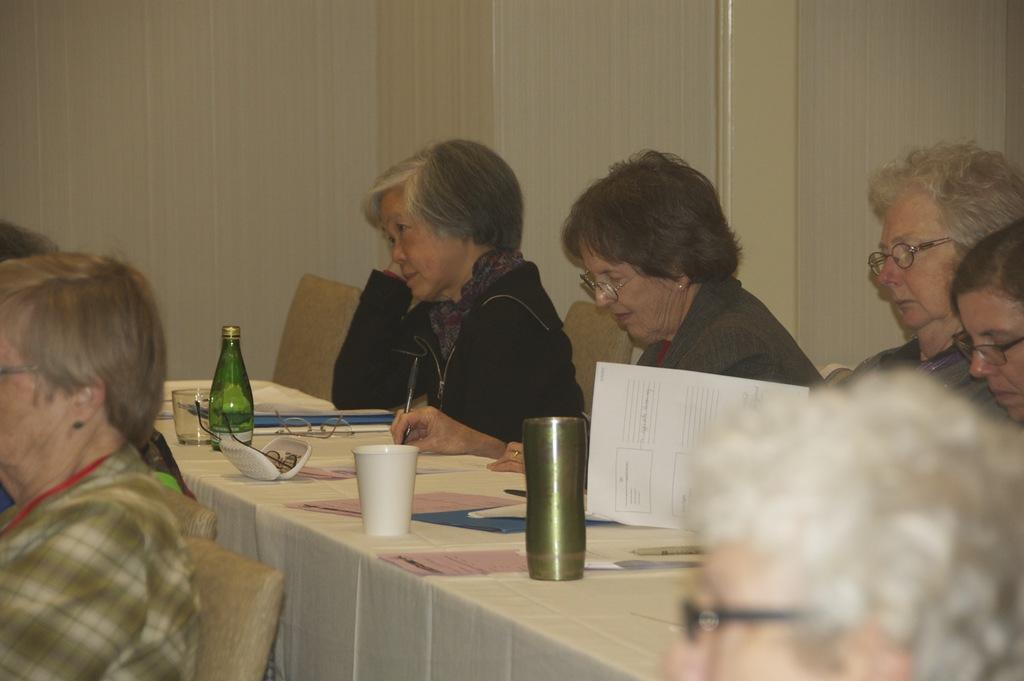What is the main subject of the image? The main subject of the image is a group of women sitting in chairs. What is located in front of the women? There is a table in front of the women. What items can be seen on the table? The table contains paper, spectacles, a mug, and a bottle. Are there any other people visible in the image? Yes, there are a few people in front of the women. What type of bone can be seen on the table in the image? There is no bone present on the table in the image. Is there any poison visible in the image? A: There is no poison visible in the image. 